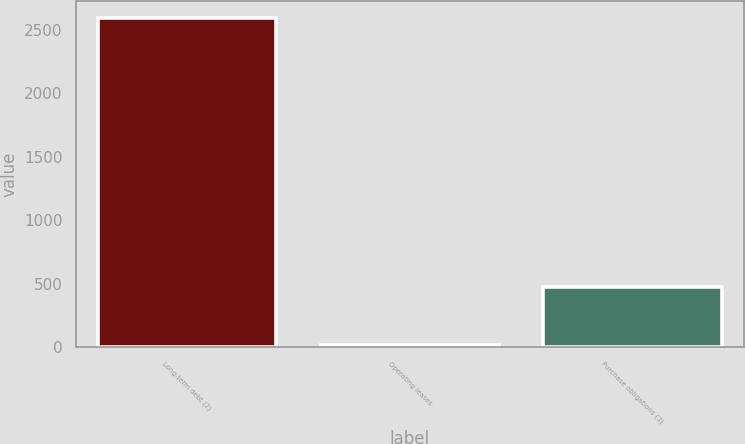Convert chart to OTSL. <chart><loc_0><loc_0><loc_500><loc_500><bar_chart><fcel>Long-term debt (2)<fcel>Operating leases<fcel>Purchase obligations (3)<nl><fcel>2595<fcel>19<fcel>471<nl></chart> 